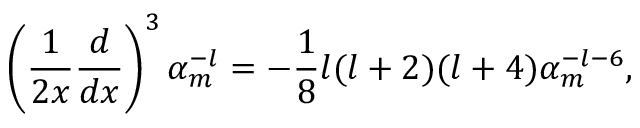<formula> <loc_0><loc_0><loc_500><loc_500>\left ( { \frac { 1 } { 2 x } } { \frac { d } { d x } } \right ) ^ { 3 } \alpha _ { m } ^ { - l } = - { \frac { 1 } { 8 } } l ( l + 2 ) ( l + 4 ) \alpha _ { m } ^ { - l - 6 } ,</formula> 